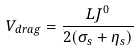<formula> <loc_0><loc_0><loc_500><loc_500>V _ { d r a g } = \frac { L J ^ { 0 } } { 2 ( \sigma _ { s } + \eta _ { s } ) }</formula> 